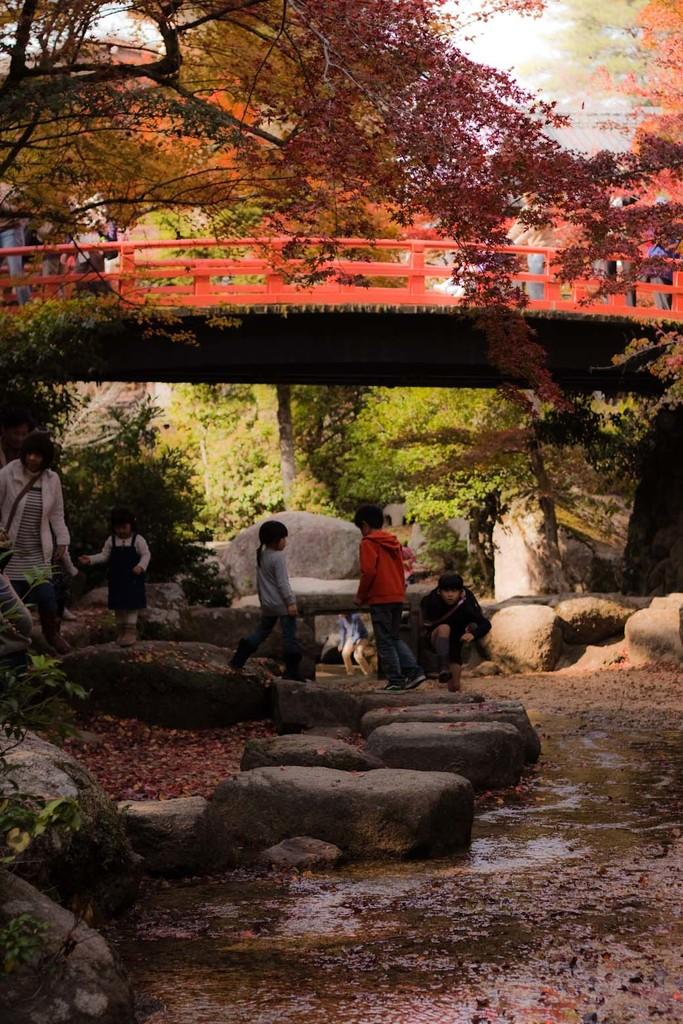What are the people in the image doing? The people in the image are standing under the bridge. What type of surface can be seen in the image? There are stones visible in the image. What natural element is present in the image? There is water in the image. What type of vegetation is in the image? There are trees in the image. What type of produce is being sold under the bridge in the image? There is no produce being sold in the image; it only shows people standing under the bridge and the surrounding environment. 